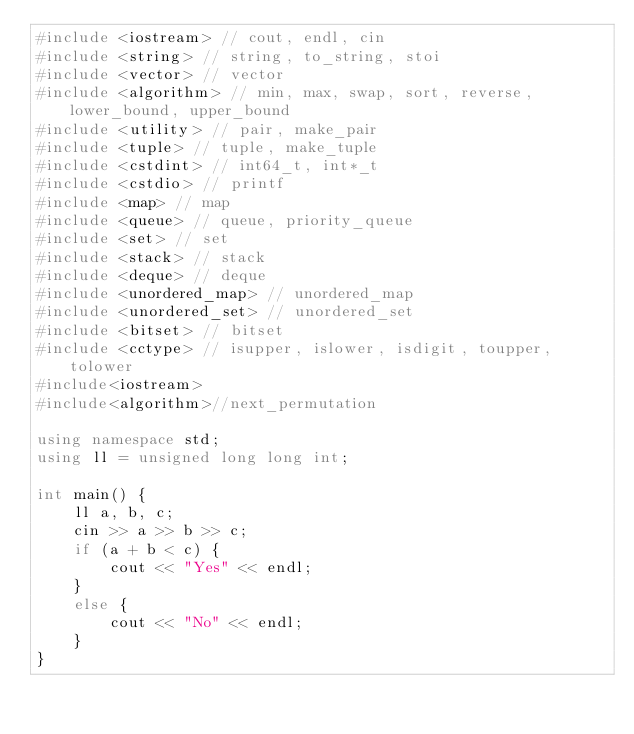Convert code to text. <code><loc_0><loc_0><loc_500><loc_500><_C++_>#include <iostream> // cout, endl, cin
#include <string> // string, to_string, stoi
#include <vector> // vector
#include <algorithm> // min, max, swap, sort, reverse, lower_bound, upper_bound
#include <utility> // pair, make_pair
#include <tuple> // tuple, make_tuple
#include <cstdint> // int64_t, int*_t
#include <cstdio> // printf
#include <map> // map
#include <queue> // queue, priority_queue
#include <set> // set
#include <stack> // stack
#include <deque> // deque
#include <unordered_map> // unordered_map
#include <unordered_set> // unordered_set
#include <bitset> // bitset
#include <cctype> // isupper, islower, isdigit, toupper, tolower
#include<iostream>
#include<algorithm>//next_permutation

using namespace std;
using ll = unsigned long long int;

int main() {
	ll a, b, c;
	cin >> a >> b >> c;
	if (a + b < c) {
		cout << "Yes" << endl;
	}
	else {
		cout << "No" << endl;
	}
}</code> 